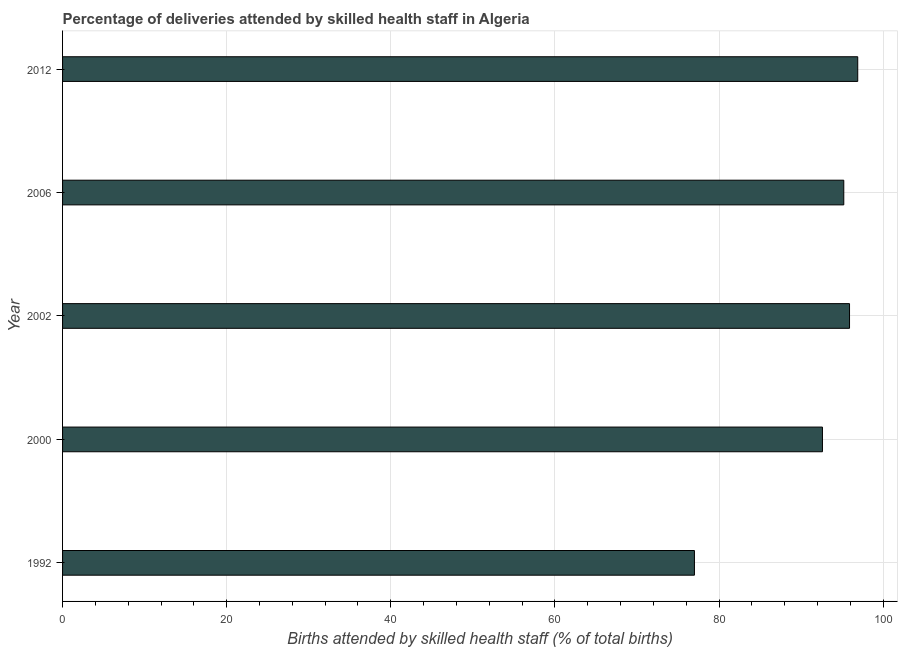Does the graph contain any zero values?
Keep it short and to the point. No. What is the title of the graph?
Keep it short and to the point. Percentage of deliveries attended by skilled health staff in Algeria. What is the label or title of the X-axis?
Ensure brevity in your answer.  Births attended by skilled health staff (% of total births). Across all years, what is the maximum number of births attended by skilled health staff?
Provide a short and direct response. 96.9. In which year was the number of births attended by skilled health staff minimum?
Offer a very short reply. 1992. What is the sum of the number of births attended by skilled health staff?
Provide a succinct answer. 457.6. What is the average number of births attended by skilled health staff per year?
Offer a terse response. 91.52. What is the median number of births attended by skilled health staff?
Offer a terse response. 95.2. In how many years, is the number of births attended by skilled health staff greater than 32 %?
Your answer should be compact. 5. What is the difference between the highest and the second highest number of births attended by skilled health staff?
Give a very brief answer. 1. In how many years, is the number of births attended by skilled health staff greater than the average number of births attended by skilled health staff taken over all years?
Keep it short and to the point. 4. How many bars are there?
Ensure brevity in your answer.  5. Are all the bars in the graph horizontal?
Make the answer very short. Yes. How many years are there in the graph?
Keep it short and to the point. 5. What is the Births attended by skilled health staff (% of total births) in 2000?
Offer a very short reply. 92.6. What is the Births attended by skilled health staff (% of total births) of 2002?
Keep it short and to the point. 95.9. What is the Births attended by skilled health staff (% of total births) in 2006?
Give a very brief answer. 95.2. What is the Births attended by skilled health staff (% of total births) in 2012?
Offer a very short reply. 96.9. What is the difference between the Births attended by skilled health staff (% of total births) in 1992 and 2000?
Make the answer very short. -15.6. What is the difference between the Births attended by skilled health staff (% of total births) in 1992 and 2002?
Your answer should be compact. -18.9. What is the difference between the Births attended by skilled health staff (% of total births) in 1992 and 2006?
Your response must be concise. -18.2. What is the difference between the Births attended by skilled health staff (% of total births) in 1992 and 2012?
Your response must be concise. -19.9. What is the difference between the Births attended by skilled health staff (% of total births) in 2000 and 2012?
Keep it short and to the point. -4.3. What is the difference between the Births attended by skilled health staff (% of total births) in 2006 and 2012?
Your response must be concise. -1.7. What is the ratio of the Births attended by skilled health staff (% of total births) in 1992 to that in 2000?
Your answer should be compact. 0.83. What is the ratio of the Births attended by skilled health staff (% of total births) in 1992 to that in 2002?
Your response must be concise. 0.8. What is the ratio of the Births attended by skilled health staff (% of total births) in 1992 to that in 2006?
Provide a short and direct response. 0.81. What is the ratio of the Births attended by skilled health staff (% of total births) in 1992 to that in 2012?
Your answer should be compact. 0.8. What is the ratio of the Births attended by skilled health staff (% of total births) in 2000 to that in 2012?
Ensure brevity in your answer.  0.96. What is the ratio of the Births attended by skilled health staff (% of total births) in 2002 to that in 2006?
Offer a very short reply. 1.01. 